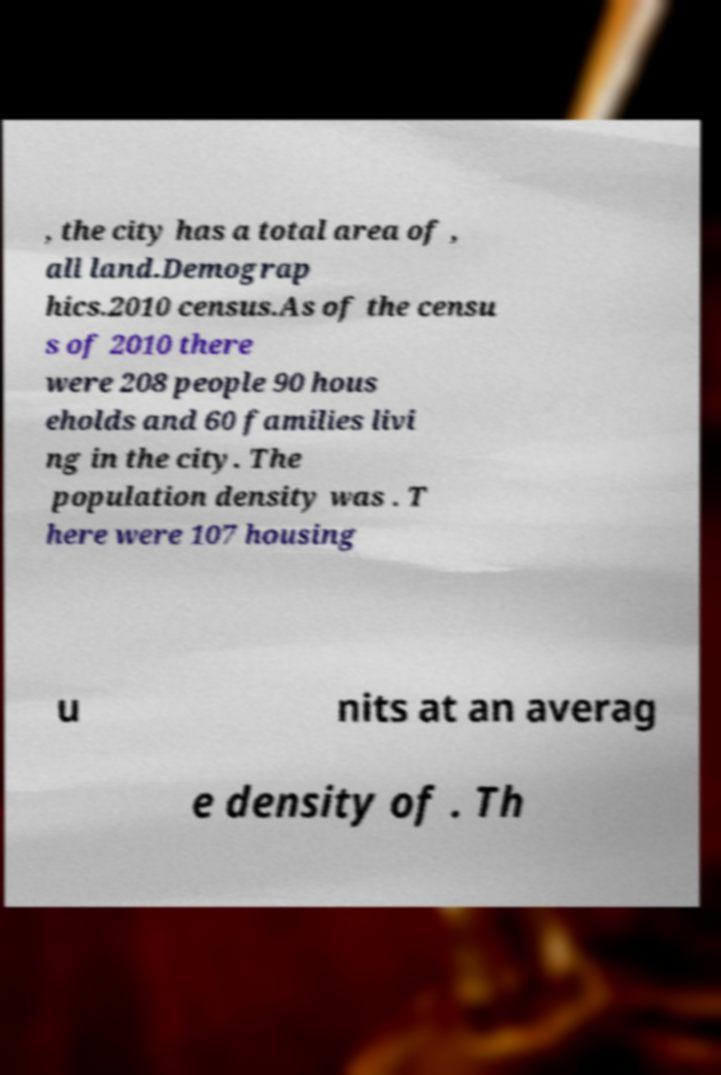Could you assist in decoding the text presented in this image and type it out clearly? , the city has a total area of , all land.Demograp hics.2010 census.As of the censu s of 2010 there were 208 people 90 hous eholds and 60 families livi ng in the city. The population density was . T here were 107 housing u nits at an averag e density of . Th 